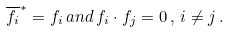Convert formula to latex. <formula><loc_0><loc_0><loc_500><loc_500>\overline { f _ { i } } ^ { \ast } = f _ { i } \, a n d \, f _ { i } \cdot f _ { j } = 0 \, , \, i \not = j \, .</formula> 